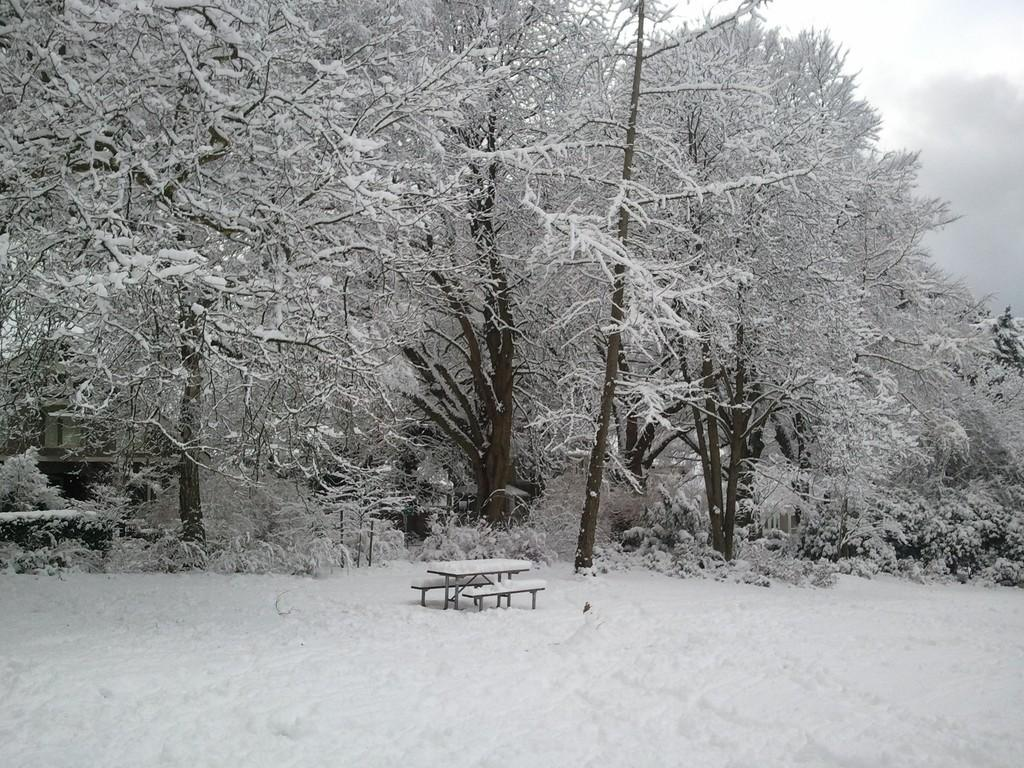What is the ground made of at the bottom of the image? There is snow at the bottom of the image. What objects can be seen in the center of the image? There are benches in the center of the image. What can be seen in the background of the image? Trees and a house are present in the background of the image. How are the trees in the background of the image affected by the weather? The trees in the background of the image are covered with snow. How many apples are hanging from the trees in the image? There are no apples visible in the image; the trees are covered with snow. Can you see a duck swimming in the snow in the image? There is no duck present in the image; it features snow, benches, trees, and a house. 